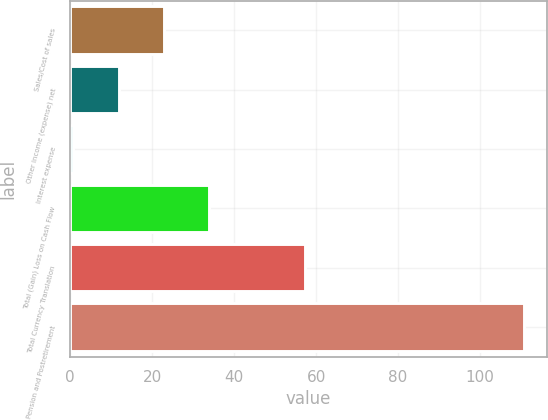Convert chart to OTSL. <chart><loc_0><loc_0><loc_500><loc_500><bar_chart><fcel>Sales/Cost of sales<fcel>Other income (expense) net<fcel>Interest expense<fcel>Total (Gain) Loss on Cash Flow<fcel>Total Currency Translation<fcel>Pension and Postretirement<nl><fcel>22.78<fcel>11.79<fcel>0.8<fcel>33.77<fcel>57.3<fcel>110.7<nl></chart> 